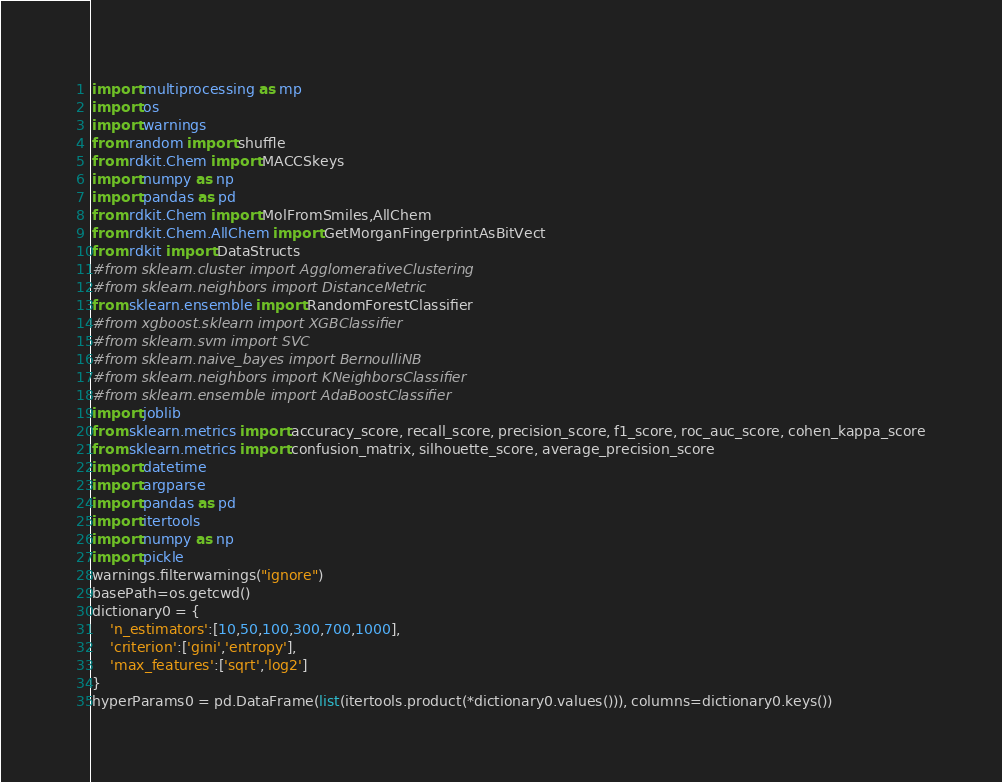<code> <loc_0><loc_0><loc_500><loc_500><_Python_>import multiprocessing as mp
import os
import warnings
from random import shuffle
from rdkit.Chem import MACCSkeys
import numpy as np
import pandas as pd
from rdkit.Chem import MolFromSmiles,AllChem
from rdkit.Chem.AllChem import GetMorganFingerprintAsBitVect
from rdkit import DataStructs
#from sklearn.cluster import AgglomerativeClustering
#from sklearn.neighbors import DistanceMetric
from sklearn.ensemble import RandomForestClassifier
#from xgboost.sklearn import XGBClassifier
#from sklearn.svm import SVC
#from sklearn.naive_bayes import BernoulliNB
#from sklearn.neighbors import KNeighborsClassifier
#from sklearn.ensemble import AdaBoostClassifier
import joblib
from sklearn.metrics import accuracy_score, recall_score, precision_score, f1_score, roc_auc_score, cohen_kappa_score
from sklearn.metrics import confusion_matrix, silhouette_score, average_precision_score
import datetime
import argparse
import pandas as pd
import itertools
import numpy as np
import pickle
warnings.filterwarnings("ignore")
basePath=os.getcwd()
dictionary0 = {
    'n_estimators':[10,50,100,300,700,1000],
    'criterion':['gini','entropy'],
    'max_features':['sqrt','log2']
}
hyperParams0 = pd.DataFrame(list(itertools.product(*dictionary0.values())), columns=dictionary0.keys())</code> 